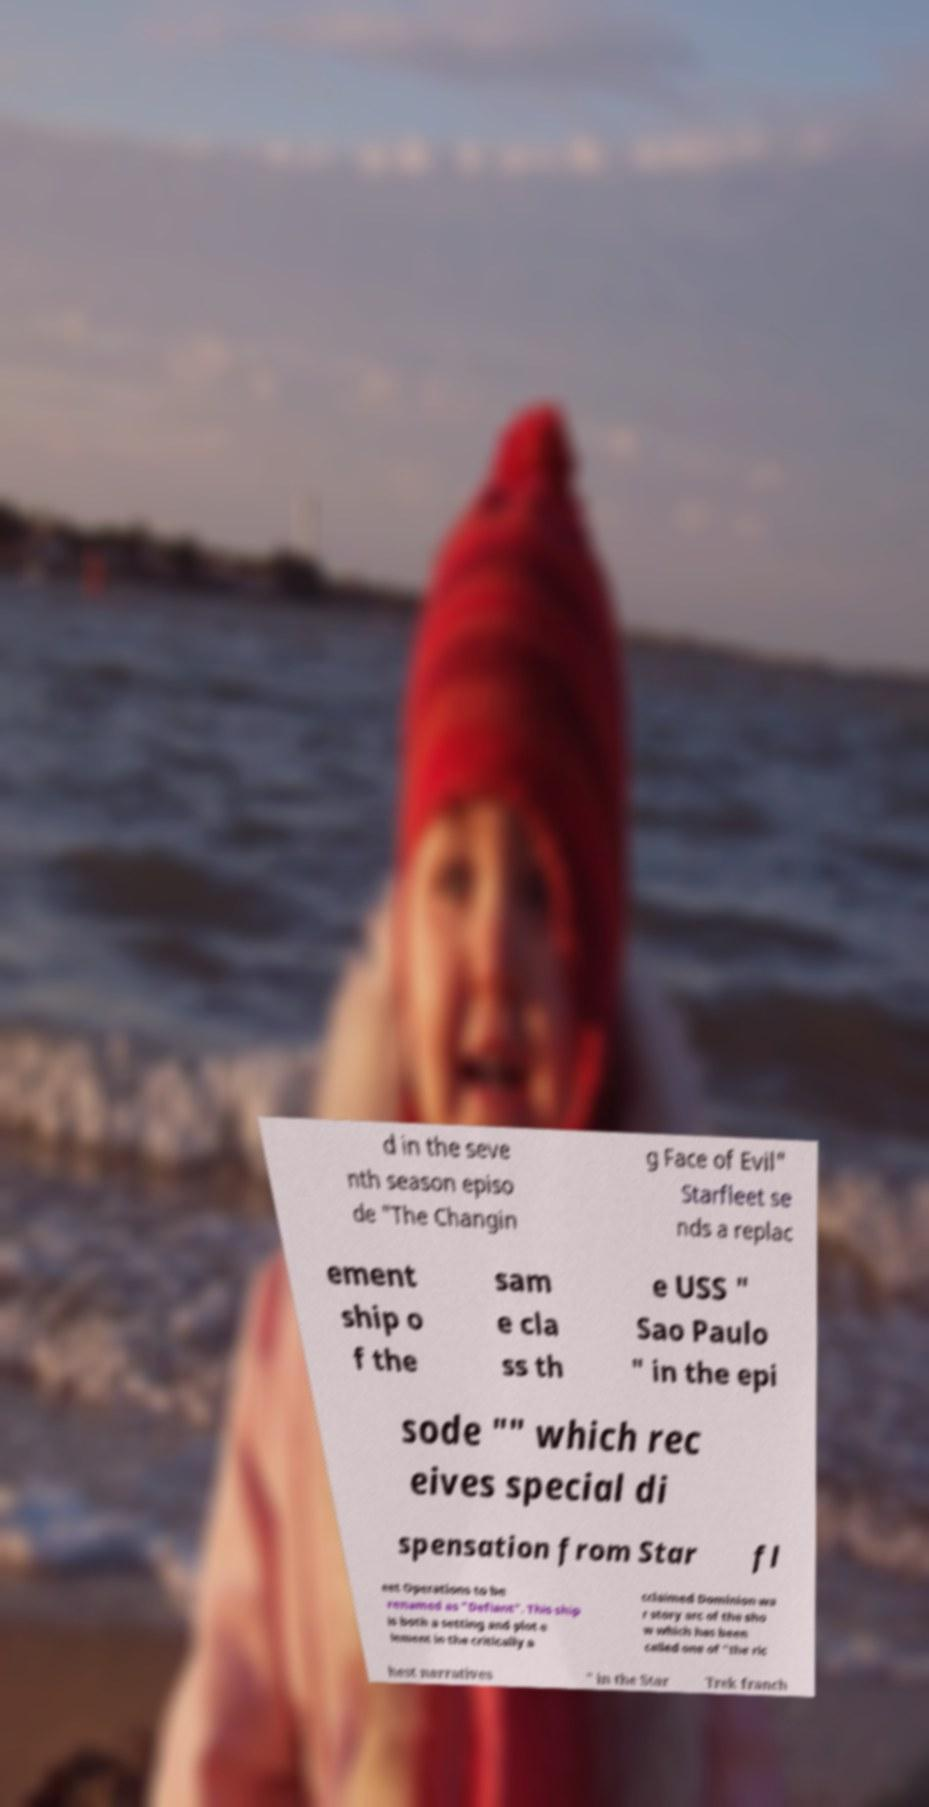I need the written content from this picture converted into text. Can you do that? d in the seve nth season episo de "The Changin g Face of Evil" Starfleet se nds a replac ement ship o f the sam e cla ss th e USS " Sao Paulo " in the epi sode "" which rec eives special di spensation from Star fl eet Operations to be renamed as "Defiant". This ship is both a setting and plot e lement in the critically a cclaimed Dominion wa r story arc of the sho w which has been called one of "the ric hest narratives " in the Star Trek franch 